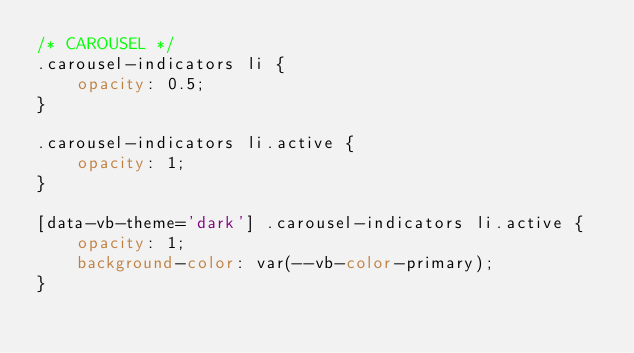Convert code to text. <code><loc_0><loc_0><loc_500><loc_500><_CSS_>/* CAROUSEL */
.carousel-indicators li {
    opacity: 0.5;
}

.carousel-indicators li.active {
    opacity: 1;
}

[data-vb-theme='dark'] .carousel-indicators li.active {
    opacity: 1;
    background-color: var(--vb-color-primary);
}
</code> 